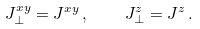Convert formula to latex. <formula><loc_0><loc_0><loc_500><loc_500>J _ { \perp } ^ { x y } = J ^ { x y } \, , \quad J _ { \perp } ^ { z } = J ^ { z } \, .</formula> 